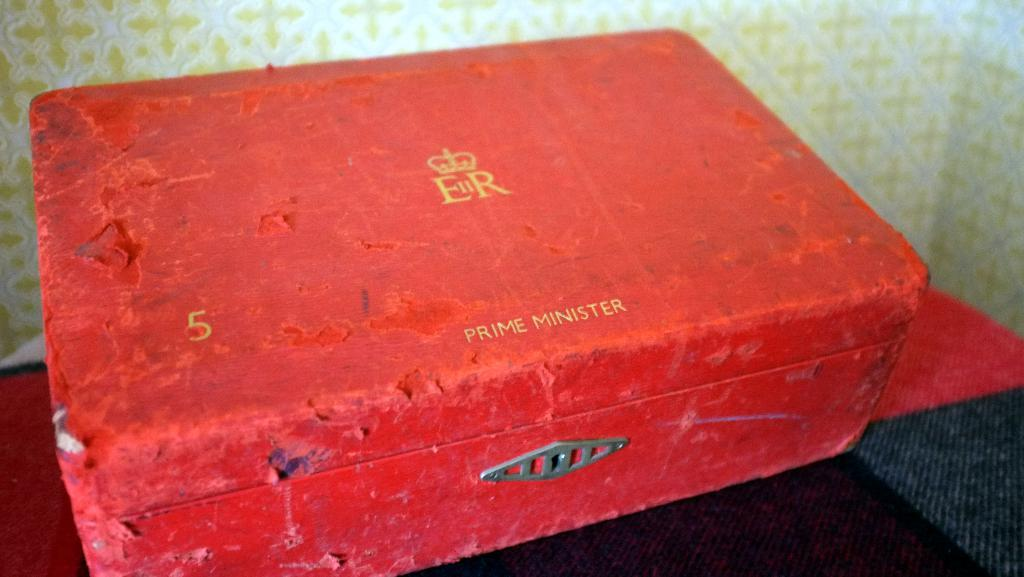Provide a one-sentence caption for the provided image. A red box that has a logo with the letters "ER" and it also says "Prime Minister". 